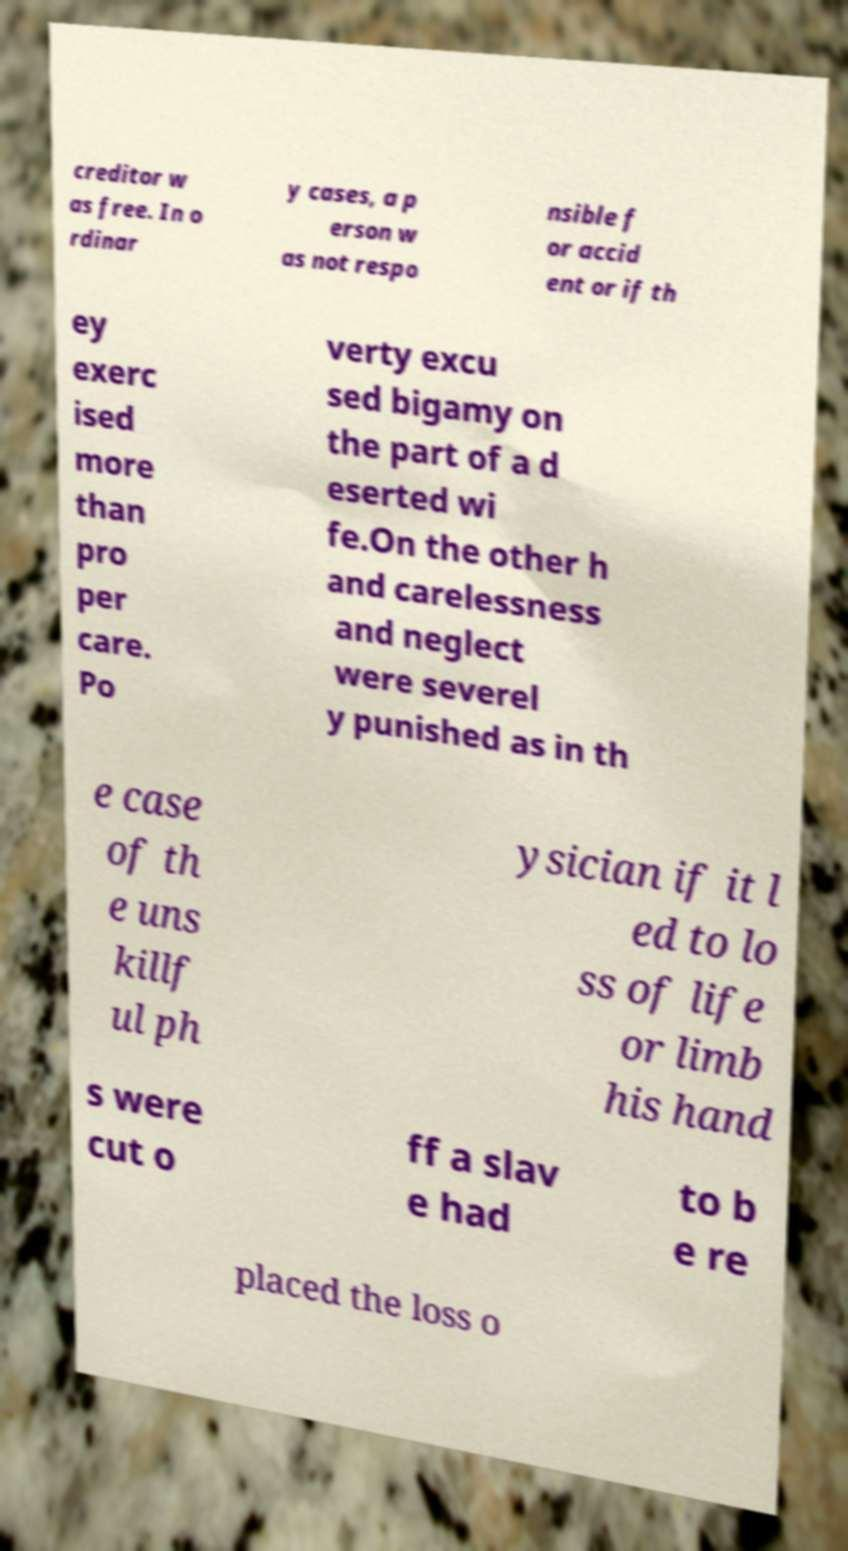I need the written content from this picture converted into text. Can you do that? creditor w as free. In o rdinar y cases, a p erson w as not respo nsible f or accid ent or if th ey exerc ised more than pro per care. Po verty excu sed bigamy on the part of a d eserted wi fe.On the other h and carelessness and neglect were severel y punished as in th e case of th e uns killf ul ph ysician if it l ed to lo ss of life or limb his hand s were cut o ff a slav e had to b e re placed the loss o 